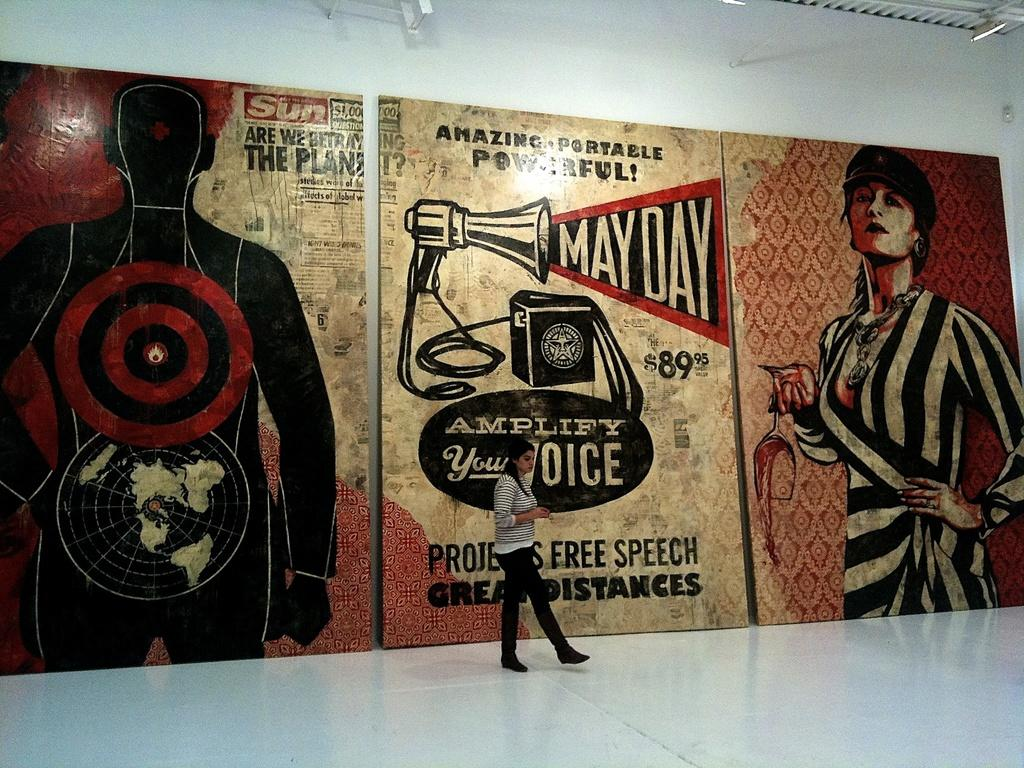What is the main subject of the image? There is a woman standing in the image. What is the woman standing on? The woman is standing on the floor. What can be seen in the background of the image? There are boards attached to the wall in the background of the image. What type of quilt is the woman using to slip in the image? There is no quilt or slipping activity present in the image. 